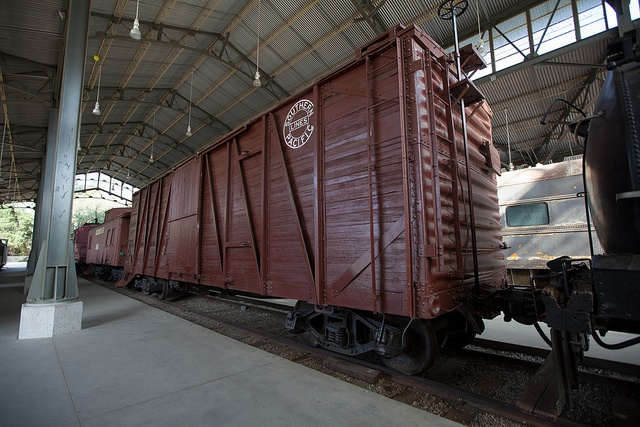Describe the objects in this image and their specific colors. I can see train in black, gray, maroon, and darkgray tones and train in black, darkgray, gray, and white tones in this image. 